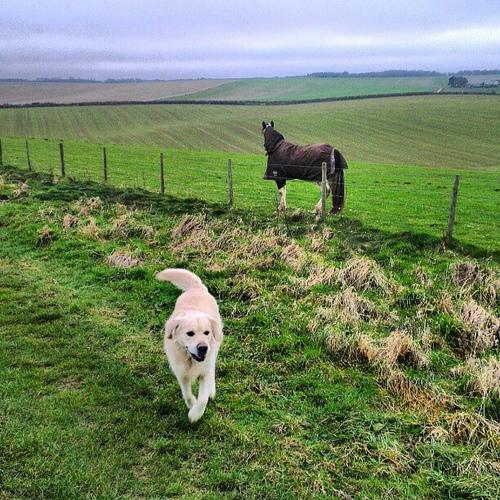Evaluate the sky's weather condition in the image. The sky has a gray overcast, indicating possible cloudy or gloomy weather. Use five adjectives to describe the image's setting. green, vast, open, pastoral, and serene What is the state of the grass in different areas of the image? lush green grass, dead brown grass, and rolling green pasture What is the total number of fence posts in the image? There are 5 fence posts in the image. Can you identify two objects that indicate this is a rural setting? Large wire fence and large tree in the pasture What is the interaction between the white dog and the brown horse? The white dog is standing near the brown horse in the pasture. Enumerate three animals that you can find in the image. white dog, brown dog, brown horse What are the sizes and colors of the noses of the two dogs? little black nose of white dog: Width: 9 Height: 9, white black nose of brown dog: Width: 17 Height: 17 What sentiment is conveyed by the image's elements such as the sky, animals, and setting? The image conveys a sense of peacefulness, calmness, and tranquility, with animals coexisting in a serene rural landscape. What color are the clouds in the sky, and how many groups of clouds are there? The clouds are white, and there are 15 groups of clouds. Can you locate a purple fence beside the horse? No, it's not mentioned in the image. 